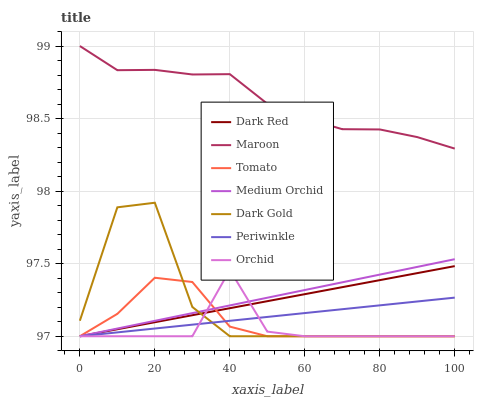Does Orchid have the minimum area under the curve?
Answer yes or no. Yes. Does Maroon have the maximum area under the curve?
Answer yes or no. Yes. Does Dark Gold have the minimum area under the curve?
Answer yes or no. No. Does Dark Gold have the maximum area under the curve?
Answer yes or no. No. Is Dark Red the smoothest?
Answer yes or no. Yes. Is Dark Gold the roughest?
Answer yes or no. Yes. Is Dark Gold the smoothest?
Answer yes or no. No. Is Dark Red the roughest?
Answer yes or no. No. Does Tomato have the lowest value?
Answer yes or no. Yes. Does Maroon have the lowest value?
Answer yes or no. No. Does Maroon have the highest value?
Answer yes or no. Yes. Does Dark Gold have the highest value?
Answer yes or no. No. Is Periwinkle less than Maroon?
Answer yes or no. Yes. Is Maroon greater than Dark Gold?
Answer yes or no. Yes. Does Periwinkle intersect Orchid?
Answer yes or no. Yes. Is Periwinkle less than Orchid?
Answer yes or no. No. Is Periwinkle greater than Orchid?
Answer yes or no. No. Does Periwinkle intersect Maroon?
Answer yes or no. No. 